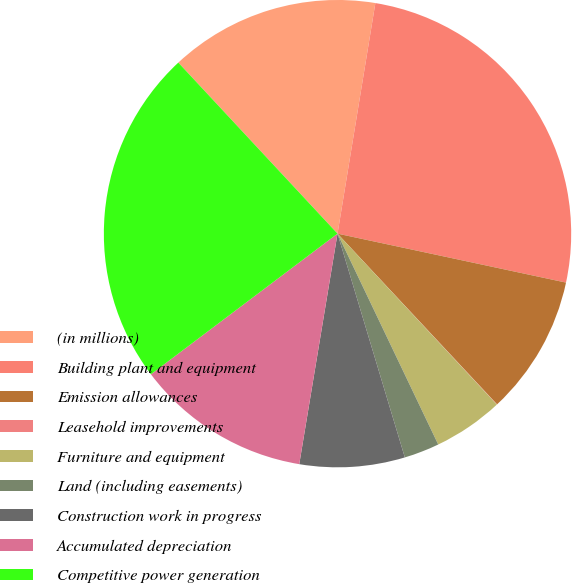<chart> <loc_0><loc_0><loc_500><loc_500><pie_chart><fcel>(in millions)<fcel>Building plant and equipment<fcel>Emission allowances<fcel>Leasehold improvements<fcel>Furniture and equipment<fcel>Land (including easements)<fcel>Construction work in progress<fcel>Accumulated depreciation<fcel>Competitive power generation<nl><fcel>14.52%<fcel>25.77%<fcel>9.68%<fcel>0.02%<fcel>4.85%<fcel>2.44%<fcel>7.27%<fcel>12.1%<fcel>23.35%<nl></chart> 